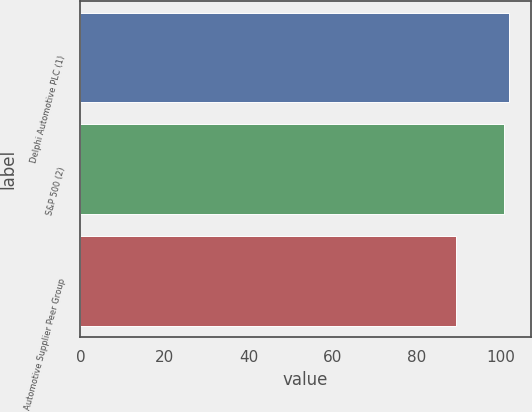Convert chart. <chart><loc_0><loc_0><loc_500><loc_500><bar_chart><fcel>Delphi Automotive PLC (1)<fcel>S&P 500 (2)<fcel>Automotive Supplier Peer Group<nl><fcel>101.97<fcel>100.8<fcel>89.27<nl></chart> 